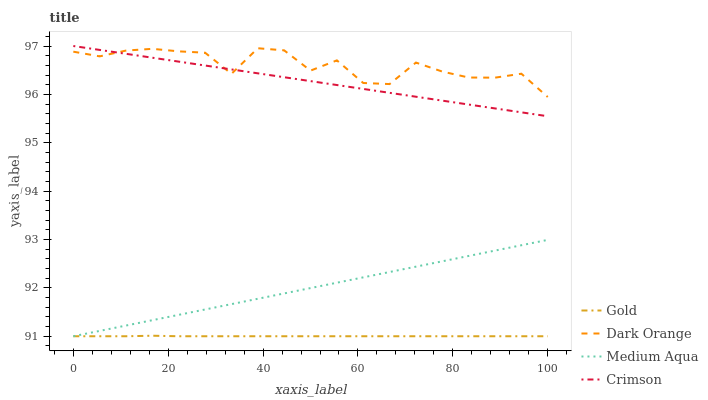Does Gold have the minimum area under the curve?
Answer yes or no. Yes. Does Dark Orange have the maximum area under the curve?
Answer yes or no. Yes. Does Medium Aqua have the minimum area under the curve?
Answer yes or no. No. Does Medium Aqua have the maximum area under the curve?
Answer yes or no. No. Is Crimson the smoothest?
Answer yes or no. Yes. Is Dark Orange the roughest?
Answer yes or no. Yes. Is Medium Aqua the smoothest?
Answer yes or no. No. Is Medium Aqua the roughest?
Answer yes or no. No. Does Medium Aqua have the lowest value?
Answer yes or no. Yes. Does Dark Orange have the lowest value?
Answer yes or no. No. Does Crimson have the highest value?
Answer yes or no. Yes. Does Dark Orange have the highest value?
Answer yes or no. No. Is Medium Aqua less than Dark Orange?
Answer yes or no. Yes. Is Crimson greater than Gold?
Answer yes or no. Yes. Does Gold intersect Medium Aqua?
Answer yes or no. Yes. Is Gold less than Medium Aqua?
Answer yes or no. No. Is Gold greater than Medium Aqua?
Answer yes or no. No. Does Medium Aqua intersect Dark Orange?
Answer yes or no. No. 